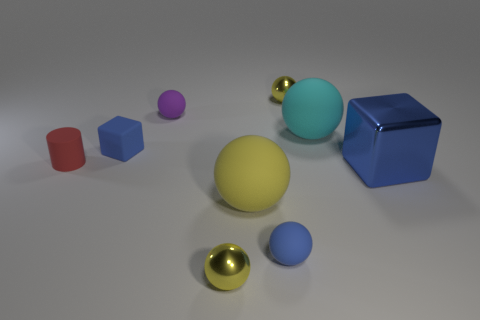How many objects are in the image and what materials do they appear to be made of? Upon close inspection, there are seven objects meticulously arrayed in the image. Their materials range from the metallic sheen on the two small spheres, evoking a sense of industrial precision, to the matte finish on the four cubes, which appear quite sturdy, possibly fashioned out of plastic or painted wood. Lastly, the large central yellow sphere has a rubbery texture that adds a tactile contrast to the scene. 